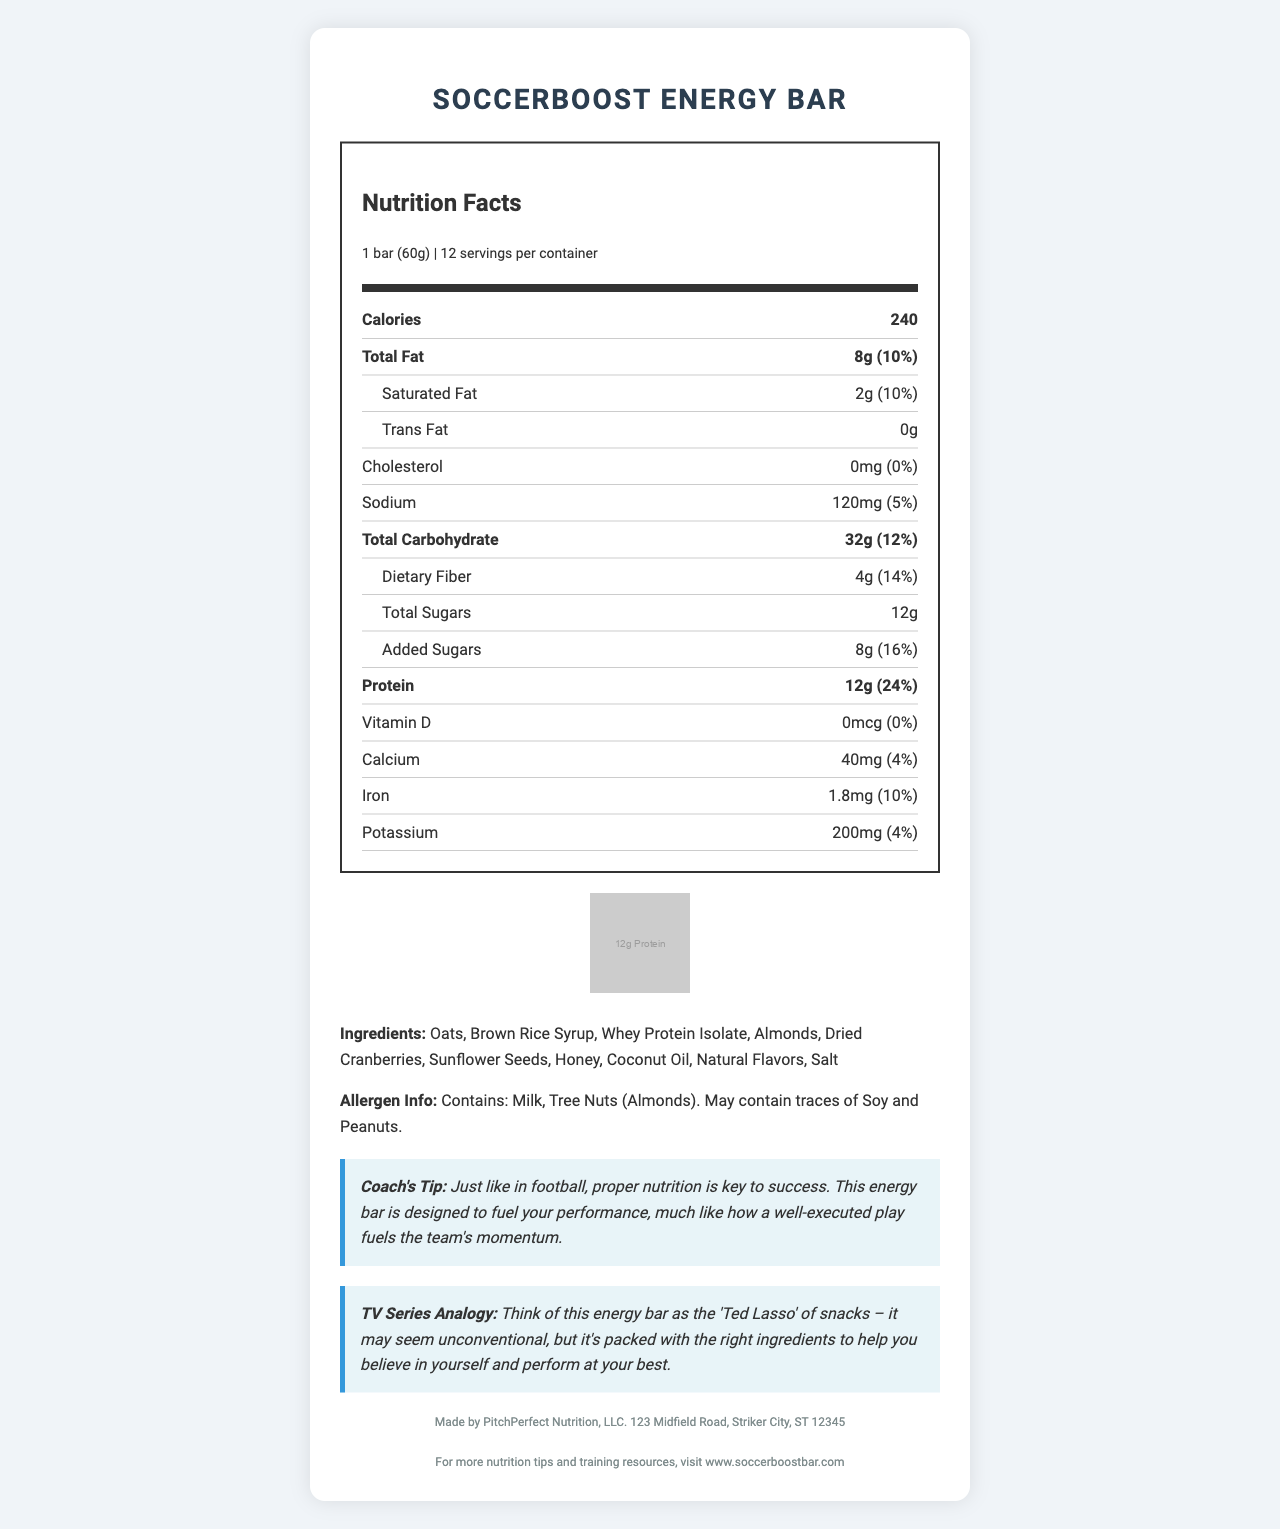How many calories are in one SoccerBoost Energy Bar? The document states that each serving, which is one bar, contains 240 calories.
Answer: 240 calories What is the serving size for SoccerBoost Energy Bar? The document indicates that the serving size for the SoccerBoost Energy Bar is 1 bar, weighing 60 grams.
Answer: 1 bar (60g) How much protein does each SoccerBoost Energy Bar contain? The document includes a soccer ball-shaped graphic and states that each bar contains 12 grams of protein.
Answer: 12g What percentage of the daily value of saturated fat does one bar provide? The document specifies that one bar contains 2 grams of saturated fat, which is 10% of the daily value.
Answer: 10% What are the main ingredients in the SoccerBoost Energy Bar? The document lists these ingredients as part of the product's description.
Answer: Oats, Brown Rice Syrup, Whey Protein Isolate, Almonds, Dried Cranberries, Sunflower Seeds, Honey, Coconut Oil, Natural Flavors, Salt Is there any trans fat in the SoccerBoost Energy Bar? The document states that the amount of trans fat is 0 grams.
Answer: No Does SoccerBoost Energy Bar contain any cholesterol? The document shows that the cholesterol content is 0mg, which is 0% of the daily value.
Answer: No How many servings are there per container? The document specifies that there are 12 servings per container.
Answer: 12 Which of the following vitamins or minerals is NOT mentioned in the SoccerBoost Energy Bar's Nutrition Facts? A. Vitamin D B. Calcium C. Vitamin C D. Iron The document mentions Vitamin D, Calcium, and Iron, but there is no mention of Vitamin C.
Answer: C. Vitamin C Which statement is correct about the SoccerBoost Energy Bar? 1. It contains peanuts as an ingredient 2. It has 16% of the daily value of added sugars 3. It has 10% of the daily value of dietary fiber The document shows that the bar has 8 grams of added sugars, which is 16% of the daily value.
Answer: 2. It has 16% of the daily value of added sugars Is there any allergen information provided for the SoccerBoost Energy Bar? The document includes allergen information stating that the product contains milk and tree nuts (almonds) and may contain soy and peanuts.
Answer: Yes Summarize the main idea of the document. The document outlines the nutritional value, benefits, and features of the energy bar, presenting it as a well-rounded option for athletes looking to enhance their performance, much like a successful strategy in football.
Answer: The document provides detailed nutrition facts, ingredient information, allergen information, and additional notes, including a coaching tip and a TV series analogy, about the SoccerBoost Energy Bar, designed to fuel performance for athletes with a balanced combination of proteins, fats, and carbohydrates. What company produces the SoccerBoost Energy Bar? The manufacturer information in the document states that the product is made by PitchPerfect Nutrition, LLC.
Answer: PitchPerfect Nutrition, LLC. Where can you find more nutrition tips and training resources for the SoccerBoost Energy Bar? The document provides a website link for additional resources related to nutrition and training for the product.
Answer: www.soccerboostbar.com How much Vitamin C does one SoccerBoost Energy Bar provide? The document does not mention Vitamin C at all, so we cannot determine its amount in one bar.
Answer: Not enough information 